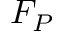<formula> <loc_0><loc_0><loc_500><loc_500>F _ { P }</formula> 